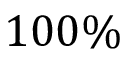Convert formula to latex. <formula><loc_0><loc_0><loc_500><loc_500>1 0 0 \%</formula> 